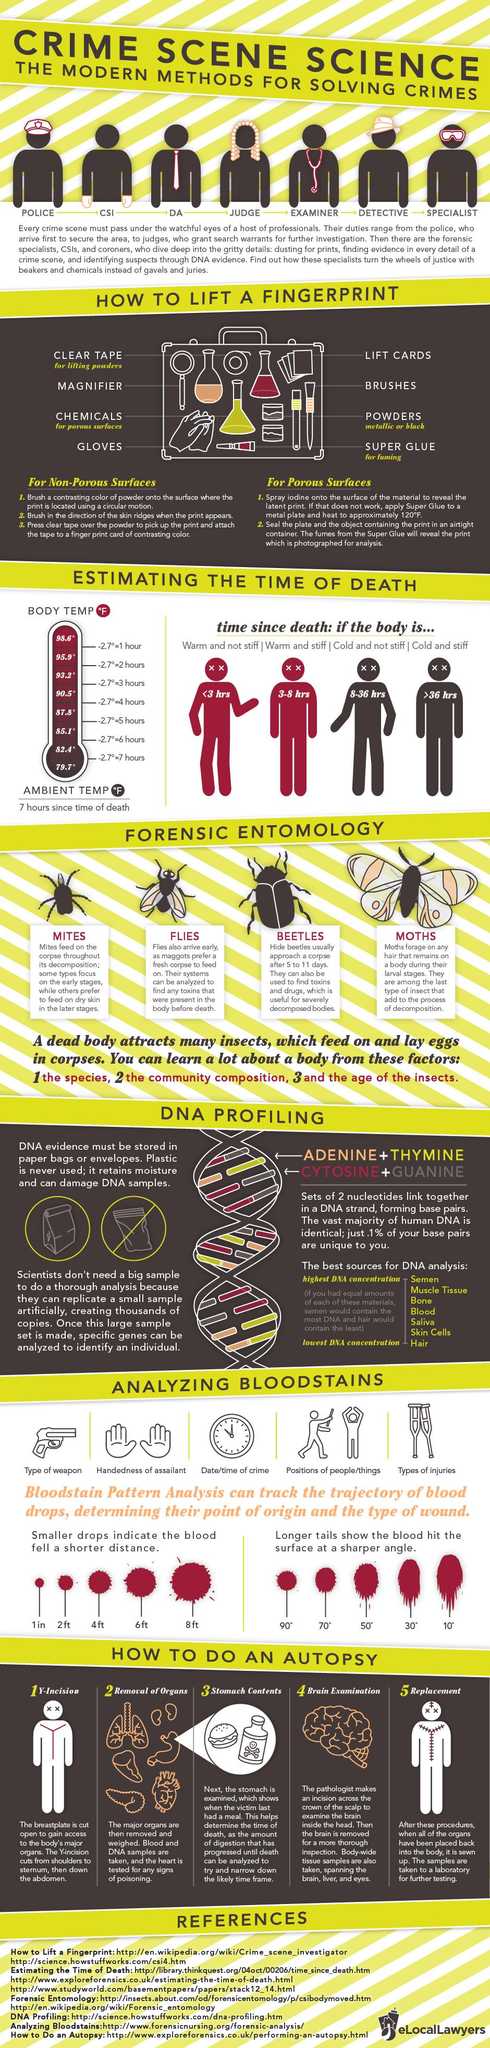Give some essential details in this illustration. Superglue fuming can be used on porous surfaces. The final step in an autopsy is the replacement of internal organs and other tissues with formalin. The body has been warm and stiff for 3 to 8 hours since the time of death. In the first three hours following death, a body typically experiences a process of warmth and relaxation, with the muscles becoming less rigid and the body becoming increasingly warm to the touch. At the time of writing, the body temperature was 95.9°F, indicating that approximately 2 hours had passed since the time of death. 